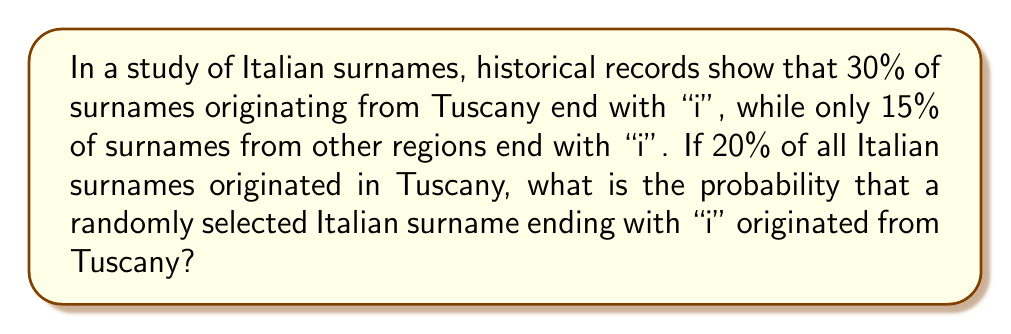Help me with this question. Let's approach this problem using Bayes' Theorem. We'll define the following events:
T: The surname originates from Tuscany
I: The surname ends with "i"

We want to find $P(T|I)$, which is the probability that a surname originated from Tuscany given that it ends with "i".

Bayes' Theorem states:

$$P(T|I) = \frac{P(I|T) \cdot P(T)}{P(I)}$$

We're given:
$P(I|T) = 0.30$ (30% of Tuscan surnames end with "i")
$P(T) = 0.20$ (20% of all Italian surnames are from Tuscany)
$P(I|\text{not }T) = 0.15$ (15% of non-Tuscan surnames end with "i")

To find $P(I)$, we use the law of total probability:
$$P(I) = P(I|T) \cdot P(T) + P(I|\text{not }T) \cdot P(\text{not }T)$$

$P(\text{not }T) = 1 - P(T) = 1 - 0.20 = 0.80$

So, $P(I) = 0.30 \cdot 0.20 + 0.15 \cdot 0.80 = 0.06 + 0.12 = 0.18$

Now we can apply Bayes' Theorem:

$$P(T|I) = \frac{0.30 \cdot 0.20}{0.18} = \frac{0.06}{0.18} = \frac{1}{3} \approx 0.3333$$

Therefore, the probability that a randomly selected Italian surname ending with "i" originated from Tuscany is approximately 0.3333 or 33.33%.
Answer: $\frac{1}{3}$ or approximately 0.3333 (33.33%) 